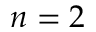<formula> <loc_0><loc_0><loc_500><loc_500>n = 2</formula> 